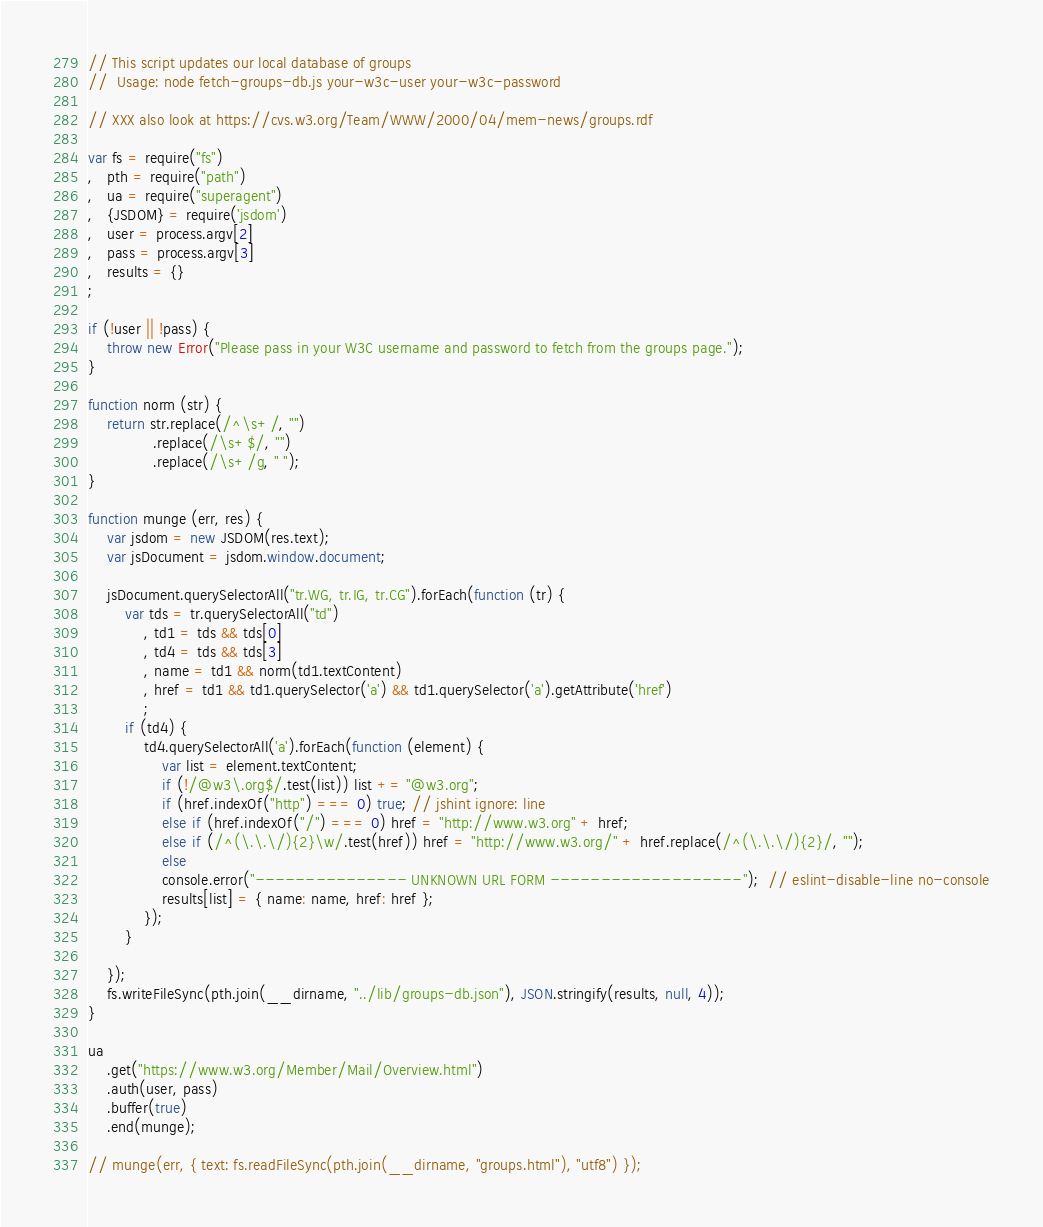Convert code to text. <code><loc_0><loc_0><loc_500><loc_500><_JavaScript_>// This script updates our local database of groups
//  Usage: node fetch-groups-db.js your-w3c-user your-w3c-password

// XXX also look at https://cvs.w3.org/Team/WWW/2000/04/mem-news/groups.rdf

var fs = require("fs")
,   pth = require("path")
,   ua = require("superagent")
,   {JSDOM} = require('jsdom')
,   user = process.argv[2]
,   pass = process.argv[3]
,   results = {}
;

if (!user || !pass) {
    throw new Error("Please pass in your W3C username and password to fetch from the groups page.");
}

function norm (str) {
    return str.replace(/^\s+/, "")
              .replace(/\s+$/, "")
              .replace(/\s+/g, " ");
}

function munge (err, res) {
    var jsdom = new JSDOM(res.text);
    var jsDocument = jsdom.window.document;

    jsDocument.querySelectorAll("tr.WG, tr.IG, tr.CG").forEach(function (tr) {
        var tds = tr.querySelectorAll("td")
            , td1 = tds && tds[0]
            , td4 = tds && tds[3]
            , name = td1 && norm(td1.textContent)
            , href = td1 && td1.querySelector('a') && td1.querySelector('a').getAttribute('href')
            ;
        if (td4) {
            td4.querySelectorAll('a').forEach(function (element) {
                var list = element.textContent;
                if (!/@w3\.org$/.test(list)) list += "@w3.org";
                if (href.indexOf("http") === 0) true; // jshint ignore: line
                else if (href.indexOf("/") === 0) href = "http://www.w3.org" + href;
                else if (/^(\.\.\/){2}\w/.test(href)) href = "http://www.w3.org/" + href.replace(/^(\.\.\/){2}/, "");
                else
                console.error("--------------- UNKNOWN URL FORM -------------------");  // eslint-disable-line no-console
                results[list] = { name: name, href: href };
            });
        }
        
    });
    fs.writeFileSync(pth.join(__dirname, "../lib/groups-db.json"), JSON.stringify(results, null, 4));
}

ua
    .get("https://www.w3.org/Member/Mail/Overview.html")
    .auth(user, pass)
    .buffer(true)
    .end(munge);

// munge(err, { text: fs.readFileSync(pth.join(__dirname, "groups.html"), "utf8") });
</code> 